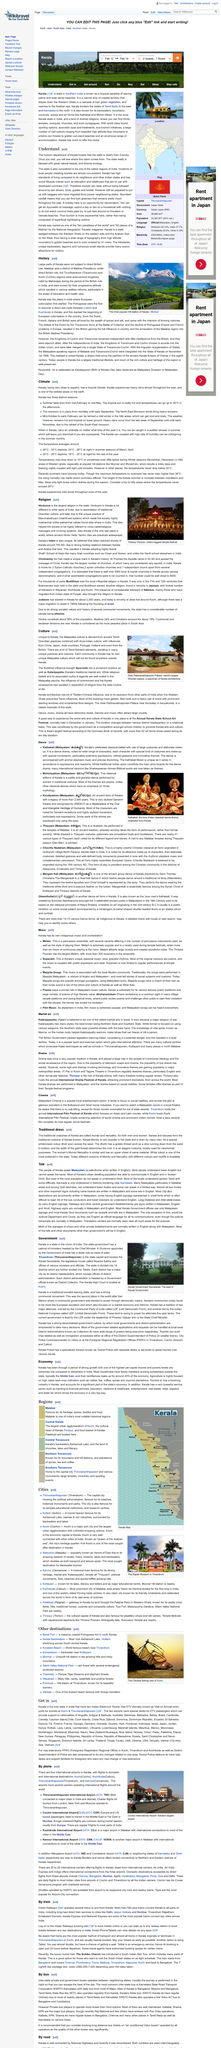Mention a couple of crucial points in this snapshot. European colonization first started in India in Kerala. The Portuguese discovered a sea route between Kozhikode and Lisbon, which was their capital city. The town shown in the picture of Kerala is Munnar. 